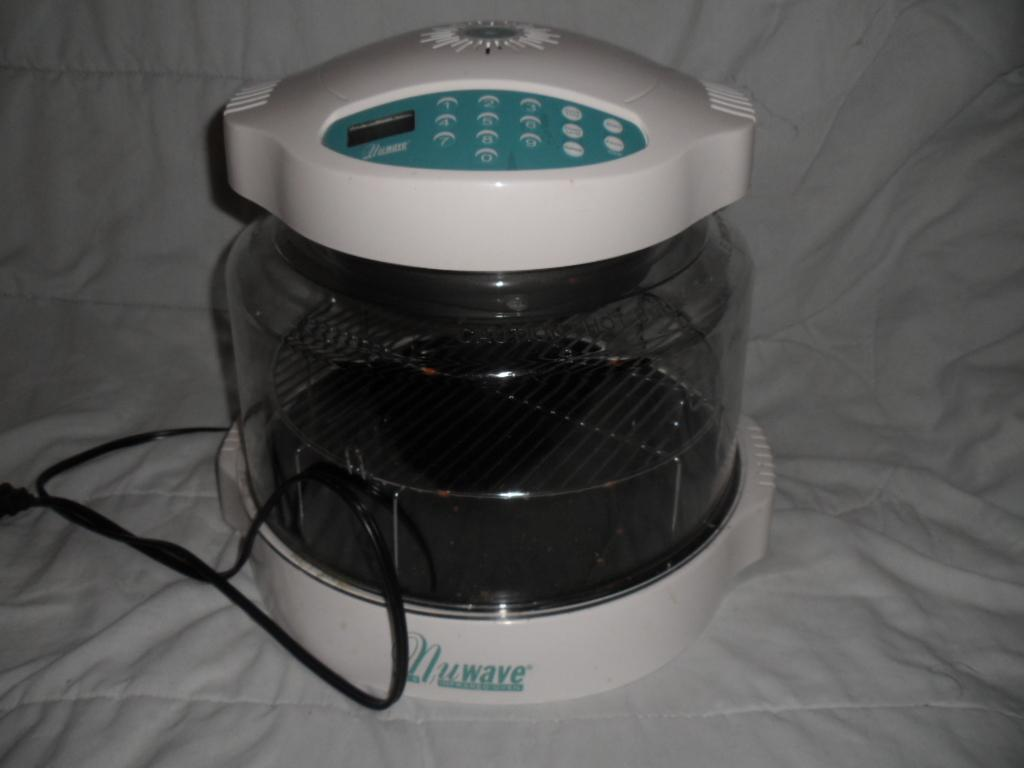<image>
Render a clear and concise summary of the photo. A Nuwave product sitting on a white cloth 